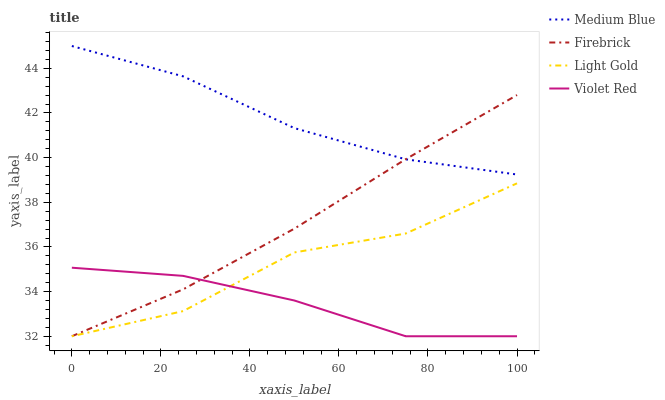Does Violet Red have the minimum area under the curve?
Answer yes or no. Yes. Does Medium Blue have the maximum area under the curve?
Answer yes or no. Yes. Does Firebrick have the minimum area under the curve?
Answer yes or no. No. Does Firebrick have the maximum area under the curve?
Answer yes or no. No. Is Firebrick the smoothest?
Answer yes or no. Yes. Is Light Gold the roughest?
Answer yes or no. Yes. Is Medium Blue the smoothest?
Answer yes or no. No. Is Medium Blue the roughest?
Answer yes or no. No. Does Light Gold have the lowest value?
Answer yes or no. Yes. Does Medium Blue have the lowest value?
Answer yes or no. No. Does Medium Blue have the highest value?
Answer yes or no. Yes. Does Firebrick have the highest value?
Answer yes or no. No. Is Light Gold less than Medium Blue?
Answer yes or no. Yes. Is Medium Blue greater than Light Gold?
Answer yes or no. Yes. Does Firebrick intersect Medium Blue?
Answer yes or no. Yes. Is Firebrick less than Medium Blue?
Answer yes or no. No. Is Firebrick greater than Medium Blue?
Answer yes or no. No. Does Light Gold intersect Medium Blue?
Answer yes or no. No. 